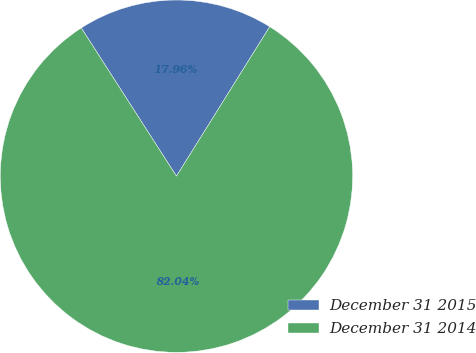Convert chart to OTSL. <chart><loc_0><loc_0><loc_500><loc_500><pie_chart><fcel>December 31 2015<fcel>December 31 2014<nl><fcel>17.96%<fcel>82.04%<nl></chart> 